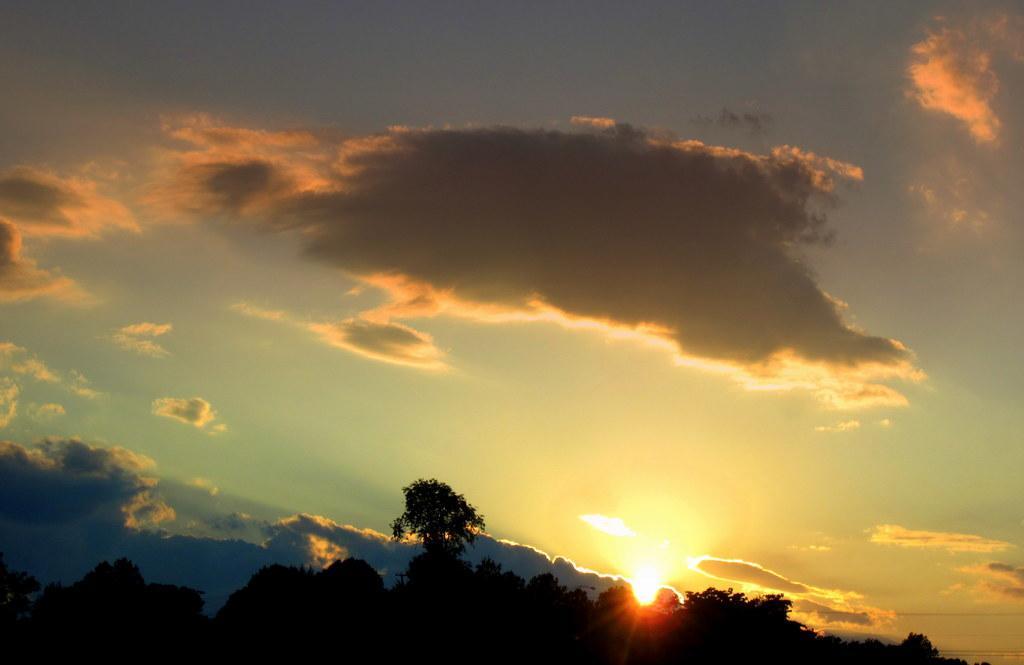Can you describe this image briefly? In this image at the bottom there are some trees, and at the top of the image there is sky and some clouds. 